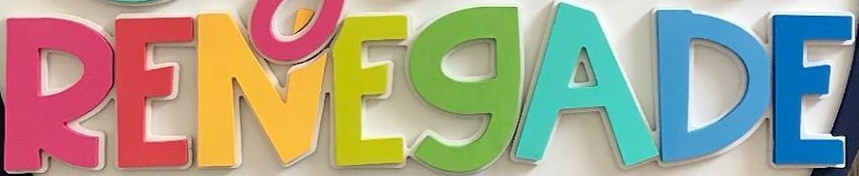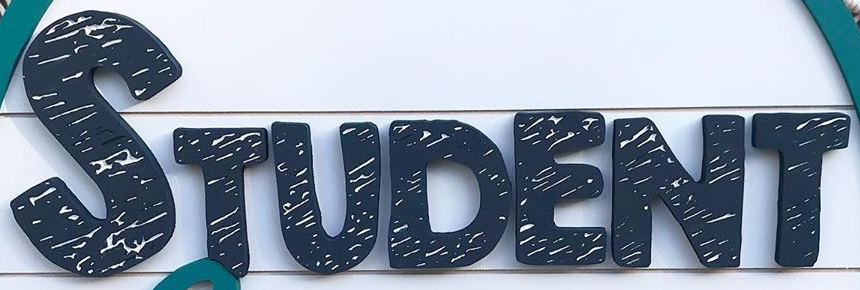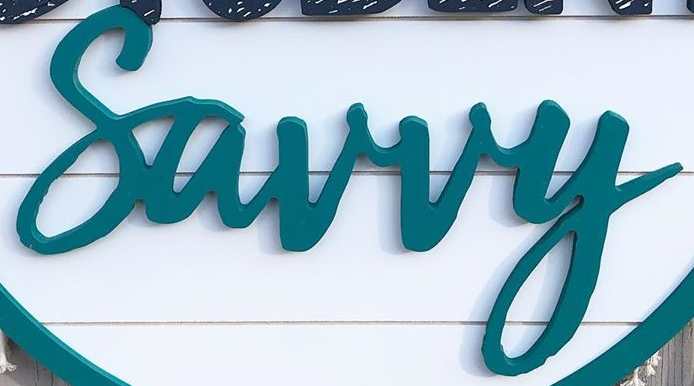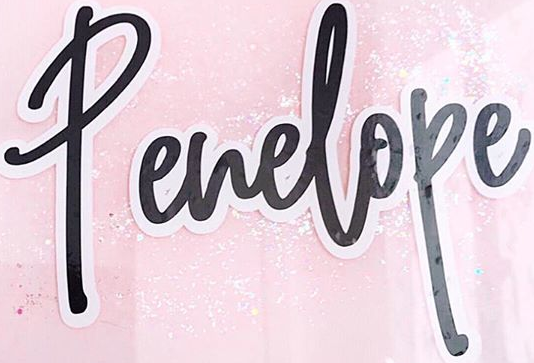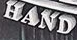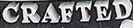Transcribe the words shown in these images in order, separated by a semicolon. RENEGADE; STUDENT; Surry; Penelope; HAND; CRAFTED 